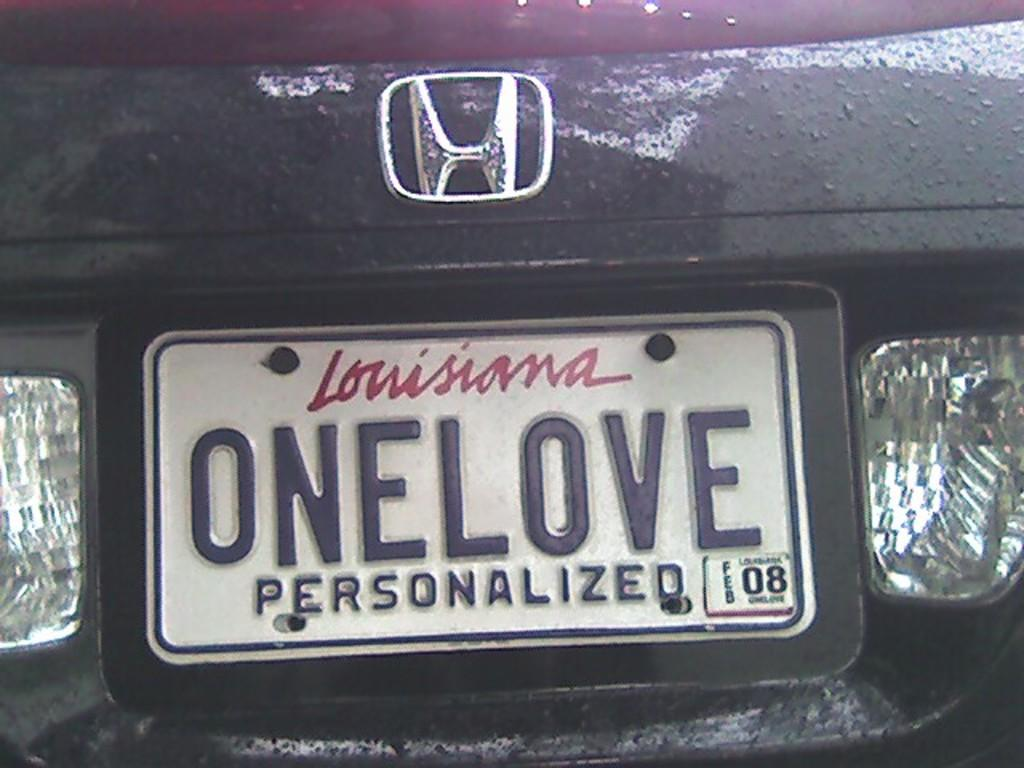<image>
Create a compact narrative representing the image presented. Louisiana license plate that says ONE LOVE in the back. 